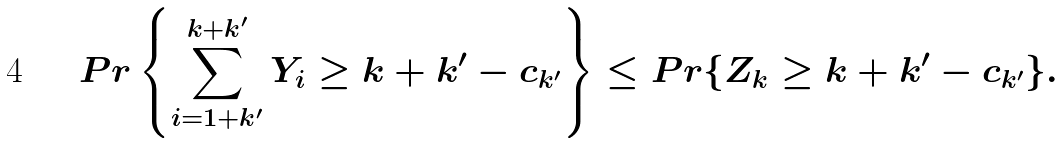<formula> <loc_0><loc_0><loc_500><loc_500>P r \left \{ \sum _ { i = 1 + k ^ { \prime } } ^ { k + k ^ { \prime } } Y _ { i } \geq k + k ^ { \prime } - c _ { k ^ { \prime } } \right \} \leq P r \{ Z _ { k } \geq k + k ^ { \prime } - c _ { k ^ { \prime } } \} .</formula> 